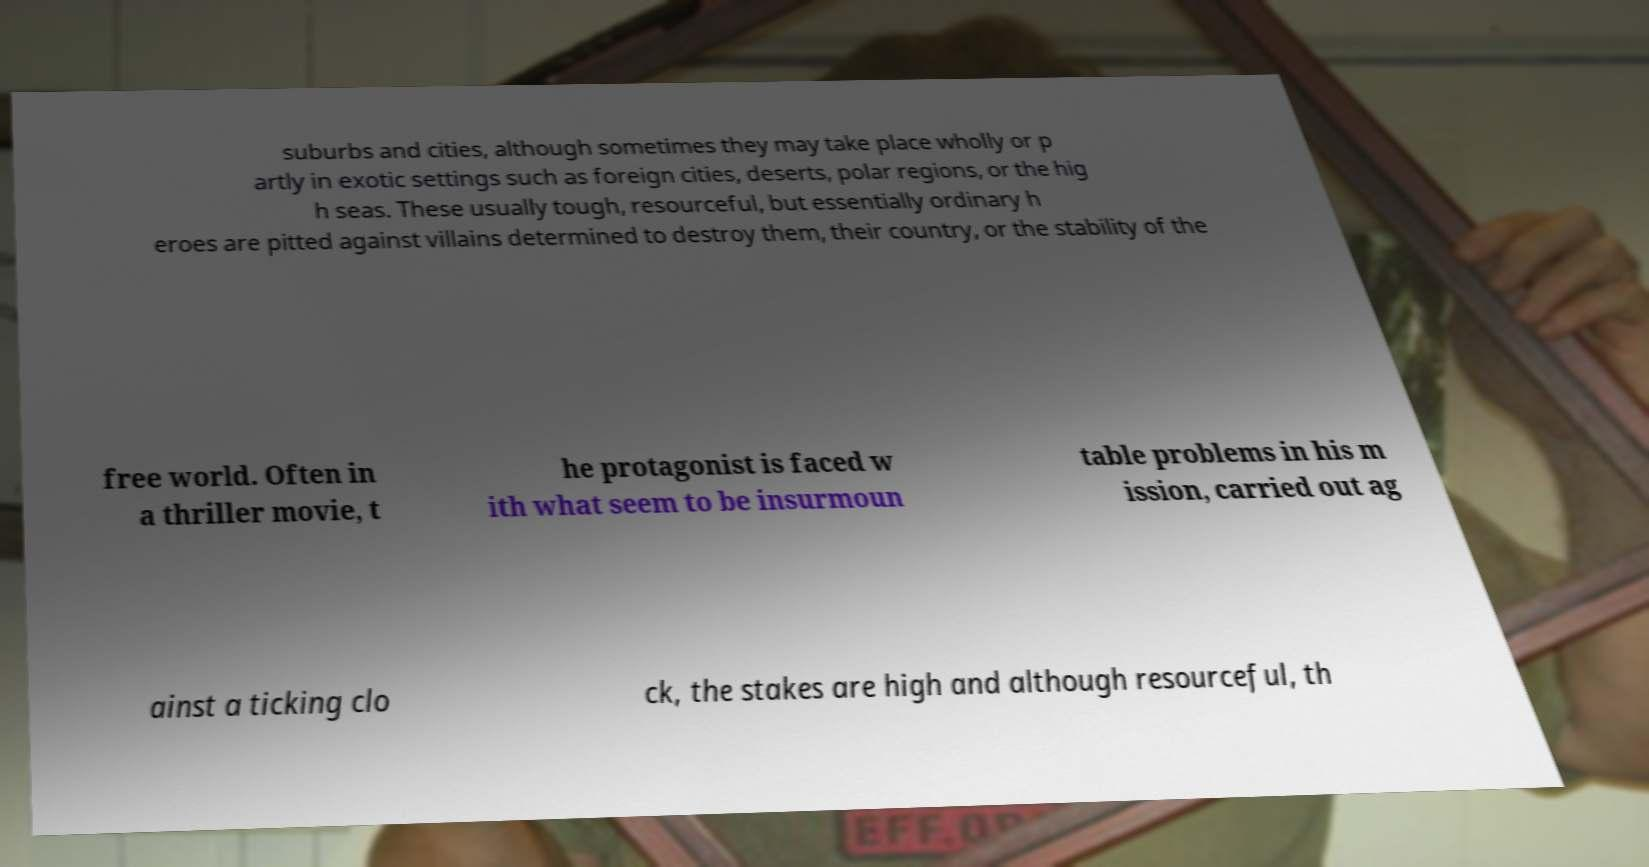For documentation purposes, I need the text within this image transcribed. Could you provide that? suburbs and cities, although sometimes they may take place wholly or p artly in exotic settings such as foreign cities, deserts, polar regions, or the hig h seas. These usually tough, resourceful, but essentially ordinary h eroes are pitted against villains determined to destroy them, their country, or the stability of the free world. Often in a thriller movie, t he protagonist is faced w ith what seem to be insurmoun table problems in his m ission, carried out ag ainst a ticking clo ck, the stakes are high and although resourceful, th 